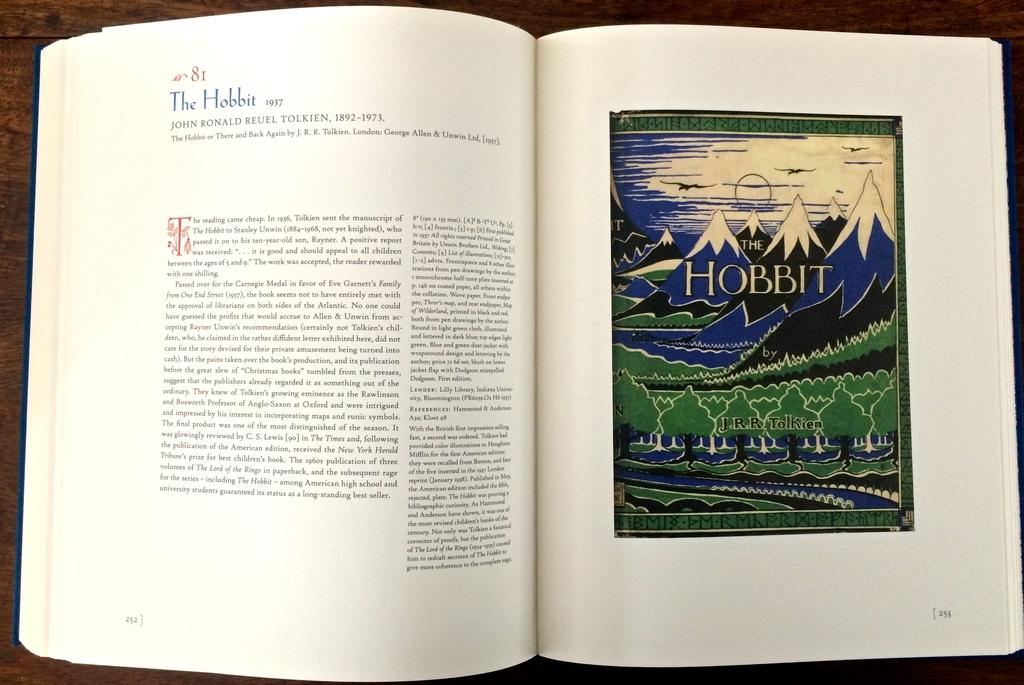<image>
Give a short and clear explanation of the subsequent image. a drawn mountain scenery  of The Hobbit printed on it. 